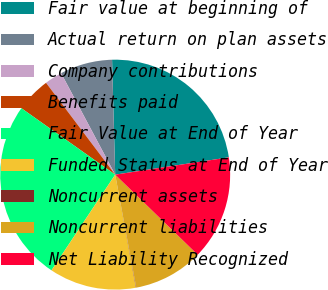<chart> <loc_0><loc_0><loc_500><loc_500><pie_chart><fcel>Fair value at beginning of<fcel>Actual return on plan assets<fcel>Company contributions<fcel>Benefits paid<fcel>Fair Value at End of Year<fcel>Funded Status at End of Year<fcel>Noncurrent assets<fcel>Noncurrent liabilities<fcel>Net Liability Recognized<nl><fcel>23.03%<fcel>7.36%<fcel>2.48%<fcel>4.92%<fcel>25.46%<fcel>12.23%<fcel>0.05%<fcel>9.8%<fcel>14.67%<nl></chart> 